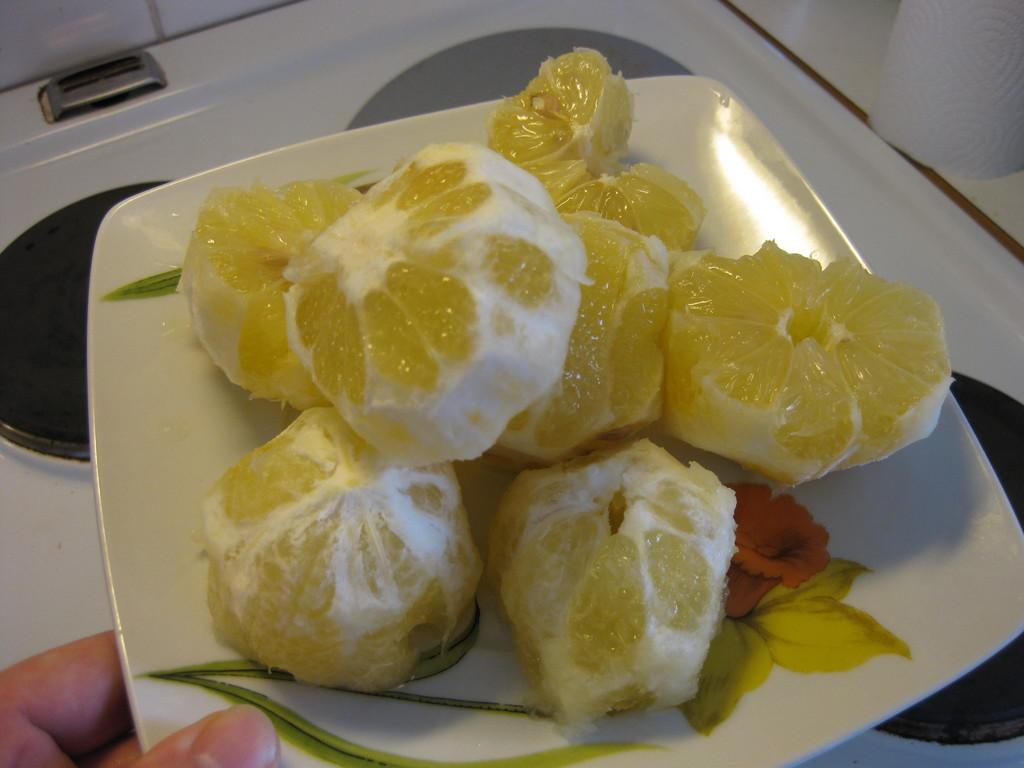What can be seen in the image? There is a hand and a white plate in the image. What is on the plate? The plate contains sweet lemons. What is the color of the background in the image? The background in the image is white. What type of haircut does the goat have in the image? There is no goat present in the image, so it is not possible to determine the type of haircut it might have. 